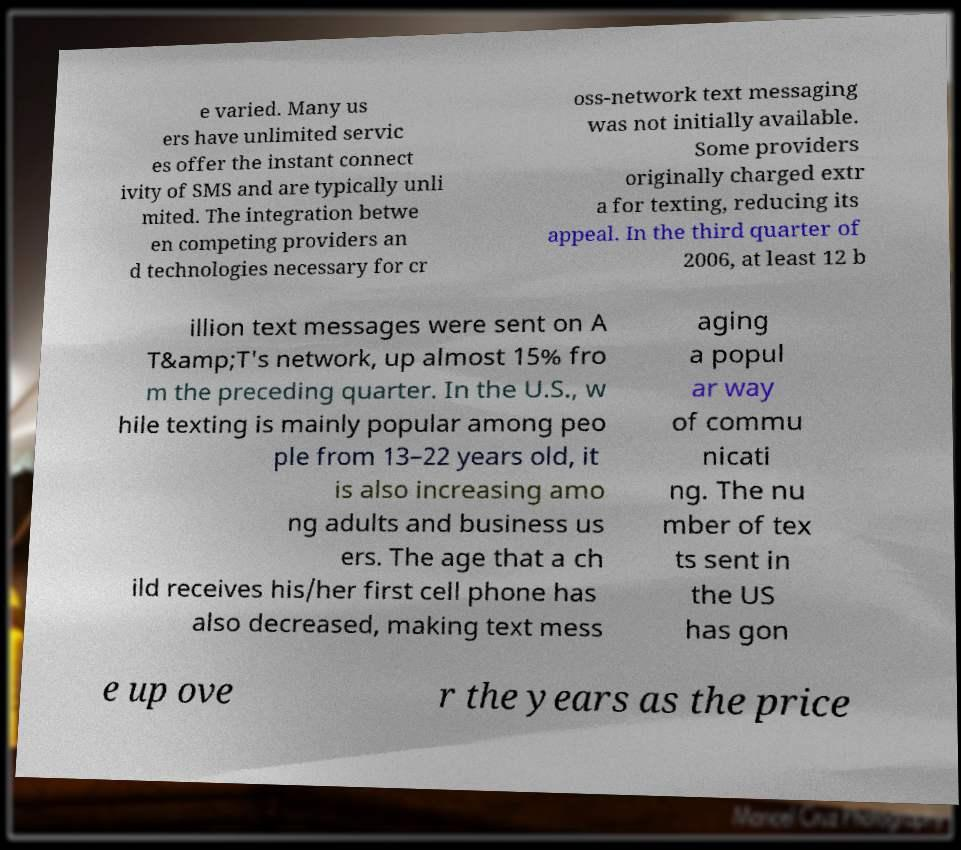Could you assist in decoding the text presented in this image and type it out clearly? e varied. Many us ers have unlimited servic es offer the instant connect ivity of SMS and are typically unli mited. The integration betwe en competing providers an d technologies necessary for cr oss-network text messaging was not initially available. Some providers originally charged extr a for texting, reducing its appeal. In the third quarter of 2006, at least 12 b illion text messages were sent on A T&amp;T's network, up almost 15% fro m the preceding quarter. In the U.S., w hile texting is mainly popular among peo ple from 13–22 years old, it is also increasing amo ng adults and business us ers. The age that a ch ild receives his/her first cell phone has also decreased, making text mess aging a popul ar way of commu nicati ng. The nu mber of tex ts sent in the US has gon e up ove r the years as the price 